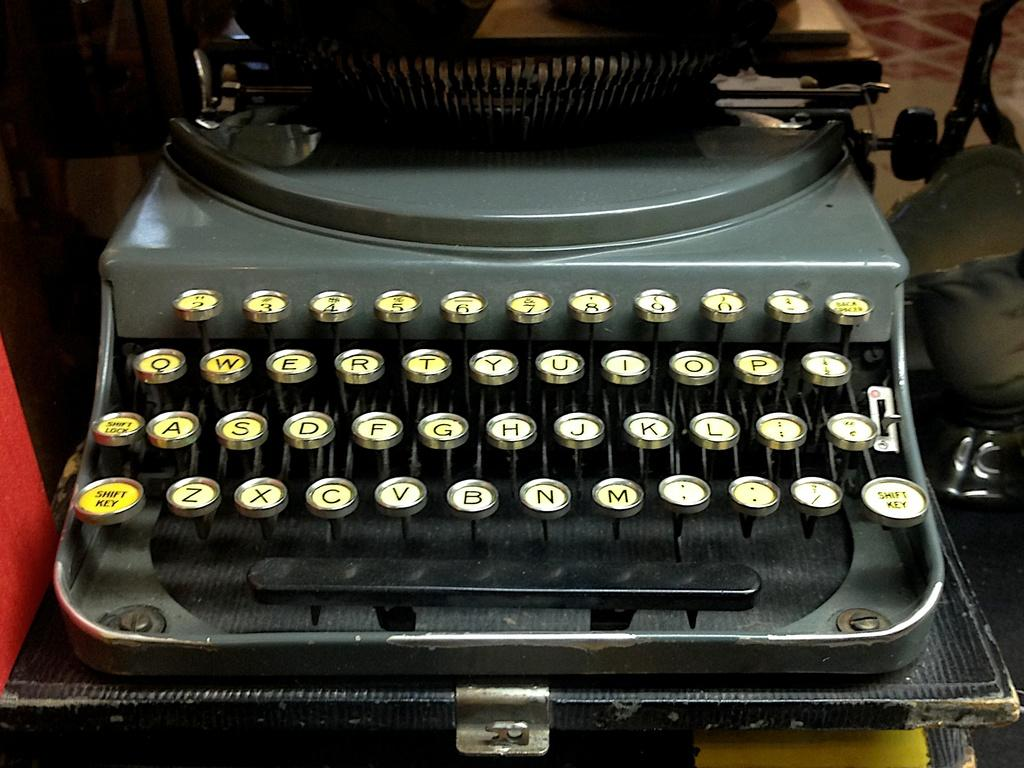Provide a one-sentence caption for the provided image. The bottom left key on the type writer is the shift key. 